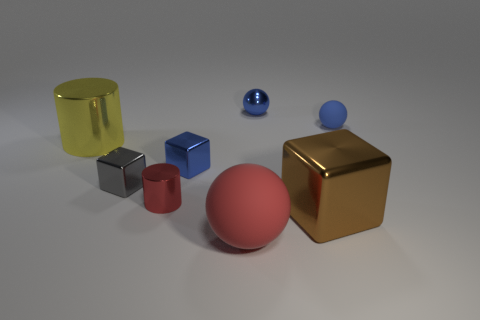Subtract all tiny blue matte spheres. How many spheres are left? 2 Add 1 small blue rubber objects. How many objects exist? 9 Subtract all yellow cylinders. How many cylinders are left? 1 Subtract all balls. How many objects are left? 5 Subtract all yellow blocks. How many yellow cylinders are left? 1 Subtract 0 brown spheres. How many objects are left? 8 Subtract 1 spheres. How many spheres are left? 2 Subtract all blue cylinders. Subtract all red balls. How many cylinders are left? 2 Subtract all big yellow cylinders. Subtract all large yellow metallic cylinders. How many objects are left? 6 Add 1 large yellow objects. How many large yellow objects are left? 2 